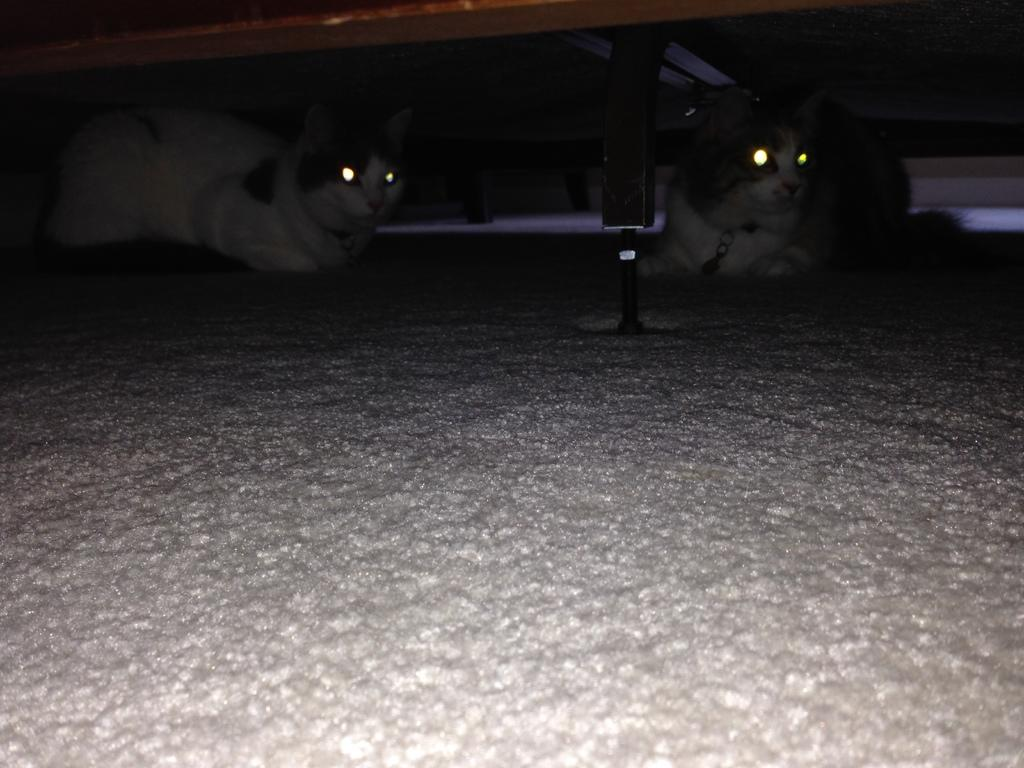How many cats are present in the image? There are two cats in the image. Where are the cats located in the image? The cats are under a cot in the image. What is the mass of the seashore depicted in the image? There is no seashore present in the image; it features two cats under a cot. 